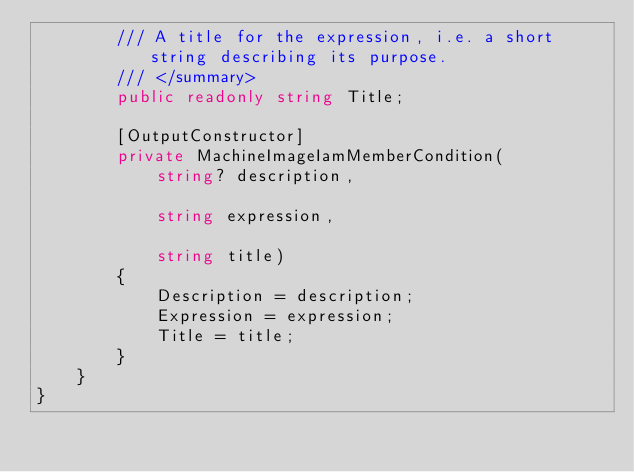Convert code to text. <code><loc_0><loc_0><loc_500><loc_500><_C#_>        /// A title for the expression, i.e. a short string describing its purpose.
        /// </summary>
        public readonly string Title;

        [OutputConstructor]
        private MachineImageIamMemberCondition(
            string? description,

            string expression,

            string title)
        {
            Description = description;
            Expression = expression;
            Title = title;
        }
    }
}
</code> 